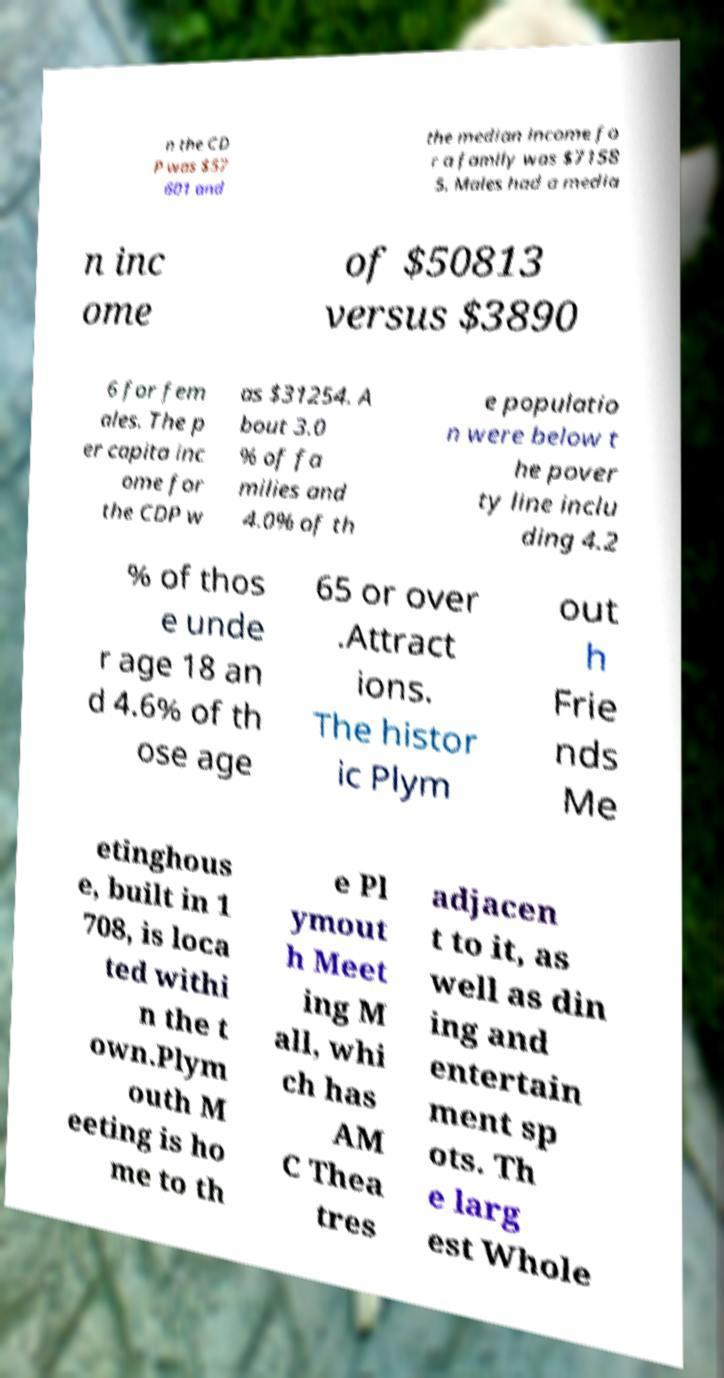Could you extract and type out the text from this image? n the CD P was $57 601 and the median income fo r a family was $7158 5. Males had a media n inc ome of $50813 versus $3890 6 for fem ales. The p er capita inc ome for the CDP w as $31254. A bout 3.0 % of fa milies and 4.0% of th e populatio n were below t he pover ty line inclu ding 4.2 % of thos e unde r age 18 an d 4.6% of th ose age 65 or over .Attract ions. The histor ic Plym out h Frie nds Me etinghous e, built in 1 708, is loca ted withi n the t own.Plym outh M eeting is ho me to th e Pl ymout h Meet ing M all, whi ch has AM C Thea tres adjacen t to it, as well as din ing and entertain ment sp ots. Th e larg est Whole 